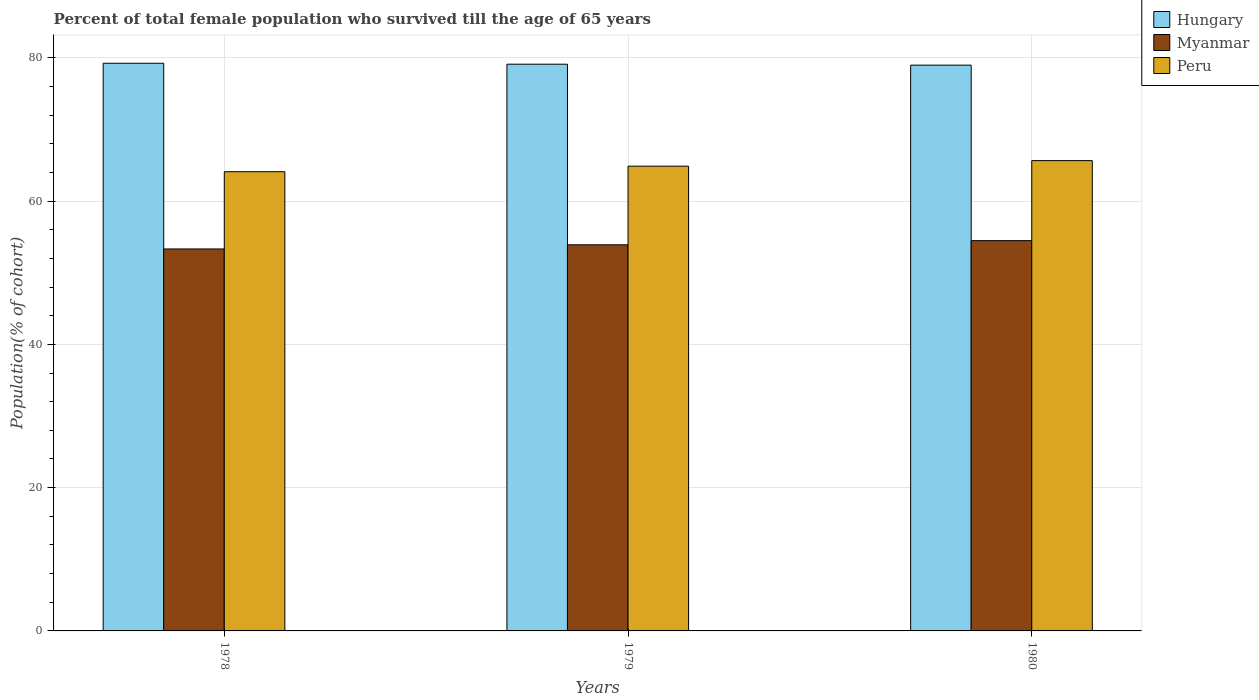How many groups of bars are there?
Provide a succinct answer. 3. What is the label of the 3rd group of bars from the left?
Your answer should be very brief. 1980. What is the percentage of total female population who survived till the age of 65 years in Myanmar in 1978?
Provide a succinct answer. 53.31. Across all years, what is the maximum percentage of total female population who survived till the age of 65 years in Myanmar?
Offer a very short reply. 54.48. Across all years, what is the minimum percentage of total female population who survived till the age of 65 years in Peru?
Offer a terse response. 64.1. In which year was the percentage of total female population who survived till the age of 65 years in Hungary maximum?
Offer a terse response. 1978. In which year was the percentage of total female population who survived till the age of 65 years in Hungary minimum?
Your response must be concise. 1980. What is the total percentage of total female population who survived till the age of 65 years in Myanmar in the graph?
Your answer should be compact. 161.68. What is the difference between the percentage of total female population who survived till the age of 65 years in Peru in 1978 and that in 1980?
Ensure brevity in your answer.  -1.55. What is the difference between the percentage of total female population who survived till the age of 65 years in Peru in 1980 and the percentage of total female population who survived till the age of 65 years in Hungary in 1979?
Keep it short and to the point. -13.46. What is the average percentage of total female population who survived till the age of 65 years in Myanmar per year?
Give a very brief answer. 53.89. In the year 1979, what is the difference between the percentage of total female population who survived till the age of 65 years in Myanmar and percentage of total female population who survived till the age of 65 years in Hungary?
Your answer should be very brief. -25.21. In how many years, is the percentage of total female population who survived till the age of 65 years in Myanmar greater than 16 %?
Your answer should be compact. 3. What is the ratio of the percentage of total female population who survived till the age of 65 years in Hungary in 1978 to that in 1979?
Ensure brevity in your answer.  1. What is the difference between the highest and the second highest percentage of total female population who survived till the age of 65 years in Myanmar?
Keep it short and to the point. 0.58. What is the difference between the highest and the lowest percentage of total female population who survived till the age of 65 years in Hungary?
Offer a terse response. 0.26. In how many years, is the percentage of total female population who survived till the age of 65 years in Peru greater than the average percentage of total female population who survived till the age of 65 years in Peru taken over all years?
Your answer should be very brief. 1. What does the 3rd bar from the right in 1979 represents?
Provide a short and direct response. Hungary. Is it the case that in every year, the sum of the percentage of total female population who survived till the age of 65 years in Peru and percentage of total female population who survived till the age of 65 years in Myanmar is greater than the percentage of total female population who survived till the age of 65 years in Hungary?
Give a very brief answer. Yes. How many years are there in the graph?
Offer a very short reply. 3. What is the difference between two consecutive major ticks on the Y-axis?
Provide a succinct answer. 20. Where does the legend appear in the graph?
Your answer should be compact. Top right. How many legend labels are there?
Provide a short and direct response. 3. What is the title of the graph?
Provide a succinct answer. Percent of total female population who survived till the age of 65 years. What is the label or title of the Y-axis?
Offer a very short reply. Population(% of cohort). What is the Population(% of cohort) in Hungary in 1978?
Ensure brevity in your answer.  79.23. What is the Population(% of cohort) of Myanmar in 1978?
Keep it short and to the point. 53.31. What is the Population(% of cohort) in Peru in 1978?
Keep it short and to the point. 64.1. What is the Population(% of cohort) of Hungary in 1979?
Give a very brief answer. 79.1. What is the Population(% of cohort) in Myanmar in 1979?
Your answer should be very brief. 53.89. What is the Population(% of cohort) in Peru in 1979?
Give a very brief answer. 64.87. What is the Population(% of cohort) of Hungary in 1980?
Your answer should be compact. 78.97. What is the Population(% of cohort) of Myanmar in 1980?
Your answer should be very brief. 54.48. What is the Population(% of cohort) of Peru in 1980?
Your response must be concise. 65.65. Across all years, what is the maximum Population(% of cohort) of Hungary?
Your answer should be very brief. 79.23. Across all years, what is the maximum Population(% of cohort) in Myanmar?
Ensure brevity in your answer.  54.48. Across all years, what is the maximum Population(% of cohort) of Peru?
Provide a succinct answer. 65.65. Across all years, what is the minimum Population(% of cohort) of Hungary?
Offer a terse response. 78.97. Across all years, what is the minimum Population(% of cohort) of Myanmar?
Your response must be concise. 53.31. Across all years, what is the minimum Population(% of cohort) of Peru?
Provide a succinct answer. 64.1. What is the total Population(% of cohort) in Hungary in the graph?
Give a very brief answer. 237.31. What is the total Population(% of cohort) of Myanmar in the graph?
Provide a succinct answer. 161.68. What is the total Population(% of cohort) of Peru in the graph?
Your answer should be very brief. 194.61. What is the difference between the Population(% of cohort) of Hungary in 1978 and that in 1979?
Keep it short and to the point. 0.13. What is the difference between the Population(% of cohort) of Myanmar in 1978 and that in 1979?
Your answer should be compact. -0.58. What is the difference between the Population(% of cohort) of Peru in 1978 and that in 1979?
Offer a terse response. -0.77. What is the difference between the Population(% of cohort) in Hungary in 1978 and that in 1980?
Give a very brief answer. 0.26. What is the difference between the Population(% of cohort) in Myanmar in 1978 and that in 1980?
Provide a succinct answer. -1.16. What is the difference between the Population(% of cohort) in Peru in 1978 and that in 1980?
Keep it short and to the point. -1.55. What is the difference between the Population(% of cohort) in Hungary in 1979 and that in 1980?
Your response must be concise. 0.13. What is the difference between the Population(% of cohort) of Myanmar in 1979 and that in 1980?
Your response must be concise. -0.58. What is the difference between the Population(% of cohort) in Peru in 1979 and that in 1980?
Your answer should be compact. -0.77. What is the difference between the Population(% of cohort) in Hungary in 1978 and the Population(% of cohort) in Myanmar in 1979?
Offer a terse response. 25.34. What is the difference between the Population(% of cohort) of Hungary in 1978 and the Population(% of cohort) of Peru in 1979?
Give a very brief answer. 14.36. What is the difference between the Population(% of cohort) in Myanmar in 1978 and the Population(% of cohort) in Peru in 1979?
Offer a very short reply. -11.56. What is the difference between the Population(% of cohort) of Hungary in 1978 and the Population(% of cohort) of Myanmar in 1980?
Your answer should be compact. 24.76. What is the difference between the Population(% of cohort) of Hungary in 1978 and the Population(% of cohort) of Peru in 1980?
Provide a short and direct response. 13.59. What is the difference between the Population(% of cohort) in Myanmar in 1978 and the Population(% of cohort) in Peru in 1980?
Ensure brevity in your answer.  -12.33. What is the difference between the Population(% of cohort) in Hungary in 1979 and the Population(% of cohort) in Myanmar in 1980?
Your response must be concise. 24.63. What is the difference between the Population(% of cohort) of Hungary in 1979 and the Population(% of cohort) of Peru in 1980?
Make the answer very short. 13.46. What is the difference between the Population(% of cohort) of Myanmar in 1979 and the Population(% of cohort) of Peru in 1980?
Offer a terse response. -11.75. What is the average Population(% of cohort) in Hungary per year?
Provide a succinct answer. 79.1. What is the average Population(% of cohort) in Myanmar per year?
Offer a terse response. 53.89. What is the average Population(% of cohort) in Peru per year?
Offer a terse response. 64.87. In the year 1978, what is the difference between the Population(% of cohort) in Hungary and Population(% of cohort) in Myanmar?
Offer a terse response. 25.92. In the year 1978, what is the difference between the Population(% of cohort) of Hungary and Population(% of cohort) of Peru?
Ensure brevity in your answer.  15.14. In the year 1978, what is the difference between the Population(% of cohort) in Myanmar and Population(% of cohort) in Peru?
Give a very brief answer. -10.78. In the year 1979, what is the difference between the Population(% of cohort) of Hungary and Population(% of cohort) of Myanmar?
Your answer should be very brief. 25.21. In the year 1979, what is the difference between the Population(% of cohort) in Hungary and Population(% of cohort) in Peru?
Ensure brevity in your answer.  14.23. In the year 1979, what is the difference between the Population(% of cohort) in Myanmar and Population(% of cohort) in Peru?
Make the answer very short. -10.98. In the year 1980, what is the difference between the Population(% of cohort) of Hungary and Population(% of cohort) of Myanmar?
Your response must be concise. 24.5. In the year 1980, what is the difference between the Population(% of cohort) of Hungary and Population(% of cohort) of Peru?
Provide a succinct answer. 13.33. In the year 1980, what is the difference between the Population(% of cohort) of Myanmar and Population(% of cohort) of Peru?
Provide a short and direct response. -11.17. What is the ratio of the Population(% of cohort) in Hungary in 1978 to that in 1980?
Keep it short and to the point. 1. What is the ratio of the Population(% of cohort) of Myanmar in 1978 to that in 1980?
Make the answer very short. 0.98. What is the ratio of the Population(% of cohort) in Peru in 1978 to that in 1980?
Your answer should be very brief. 0.98. What is the ratio of the Population(% of cohort) in Hungary in 1979 to that in 1980?
Provide a succinct answer. 1. What is the ratio of the Population(% of cohort) of Myanmar in 1979 to that in 1980?
Give a very brief answer. 0.99. What is the difference between the highest and the second highest Population(% of cohort) in Hungary?
Ensure brevity in your answer.  0.13. What is the difference between the highest and the second highest Population(% of cohort) in Myanmar?
Offer a terse response. 0.58. What is the difference between the highest and the second highest Population(% of cohort) of Peru?
Make the answer very short. 0.77. What is the difference between the highest and the lowest Population(% of cohort) in Hungary?
Ensure brevity in your answer.  0.26. What is the difference between the highest and the lowest Population(% of cohort) of Myanmar?
Your answer should be compact. 1.16. What is the difference between the highest and the lowest Population(% of cohort) of Peru?
Your answer should be compact. 1.55. 